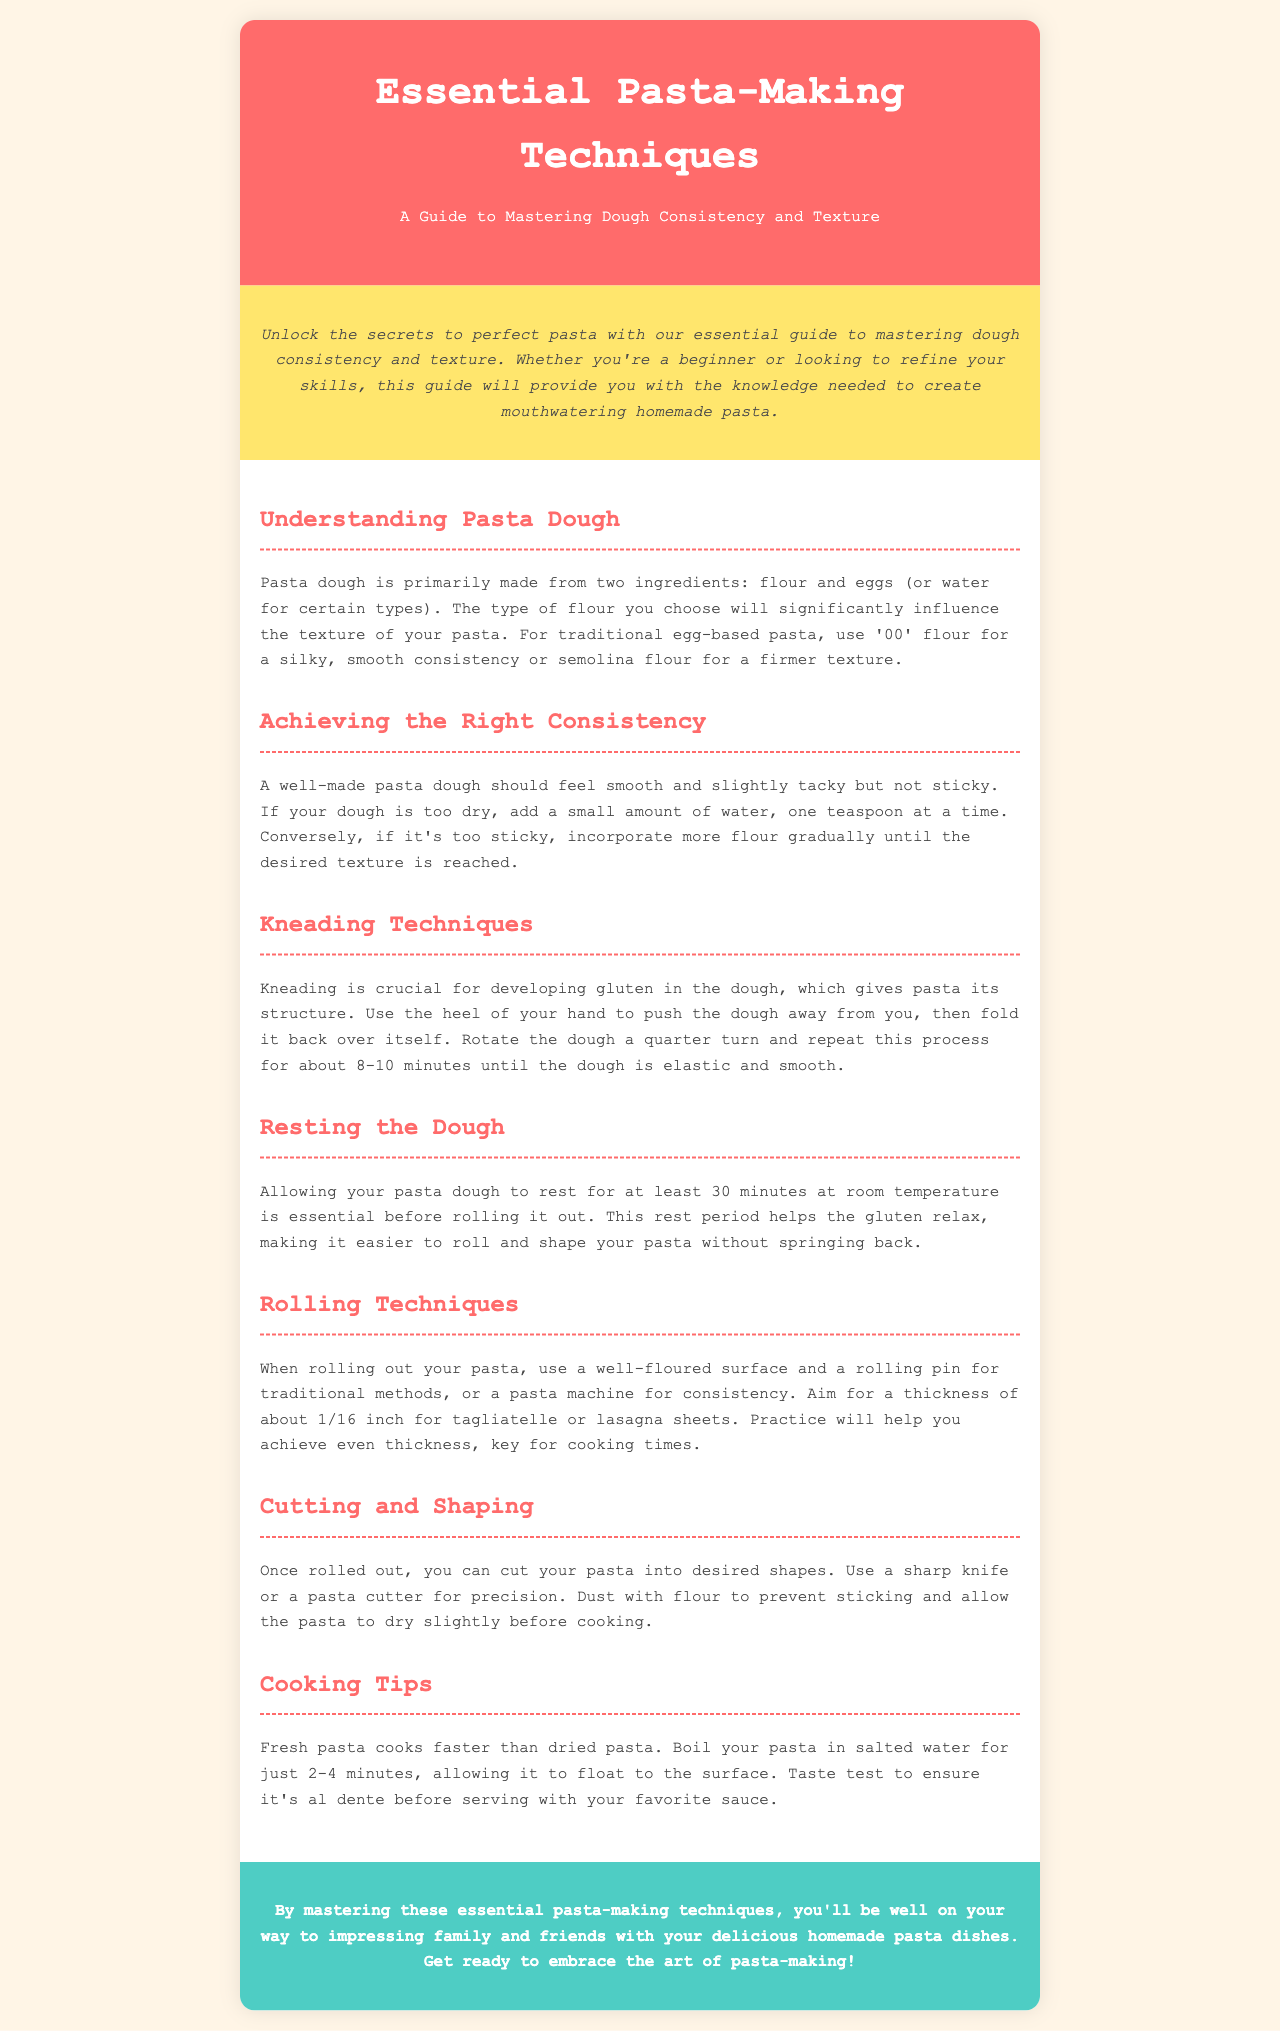What are the two primary ingredients of pasta dough? The primary ingredients of pasta dough are listed in the section "Understanding Pasta Dough" as flour and eggs (or water for certain types).
Answer: flour and eggs What type of flour is recommended for a silky, smooth consistency? The document specifies in the "Understanding Pasta Dough" section that '00' flour is recommended for silky, smooth consistency.
Answer: '00' flour How long should pasta dough rest before rolling out? In the "Resting the Dough" section, it is mentioned that pasta dough should rest for at least 30 minutes at room temperature.
Answer: 30 minutes What is the thickness target for tagliatelle sheets? The "Rolling Techniques" section states that the target thickness for tagliatelle sheets is about 1/16 inch.
Answer: 1/16 inch What does kneading help develop in pasta dough? The "Kneading Techniques" section explains that kneading is crucial for developing gluten in the dough.
Answer: gluten Describe the cooking time for fresh pasta. The "Cooking Tips" section mentions that fresh pasta cooks for just 2-4 minutes.
Answer: 2-4 minutes Why is it important to dust cut pasta with flour? The "Cutting and Shaping" section advises dusting pasta with flour to prevent sticking.
Answer: to prevent sticking Which technique is essential for achieving the right dough consistency? The "Achieving the Right Consistency" section highlights that adding water or flour gradually is essential for achieving the right consistency.
Answer: adding water or flour gradually What type of document is this? This document is a guide specifically for mastering pasta-making techniques.
Answer: brochure 